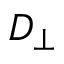<formula> <loc_0><loc_0><loc_500><loc_500>D _ { \perp }</formula> 